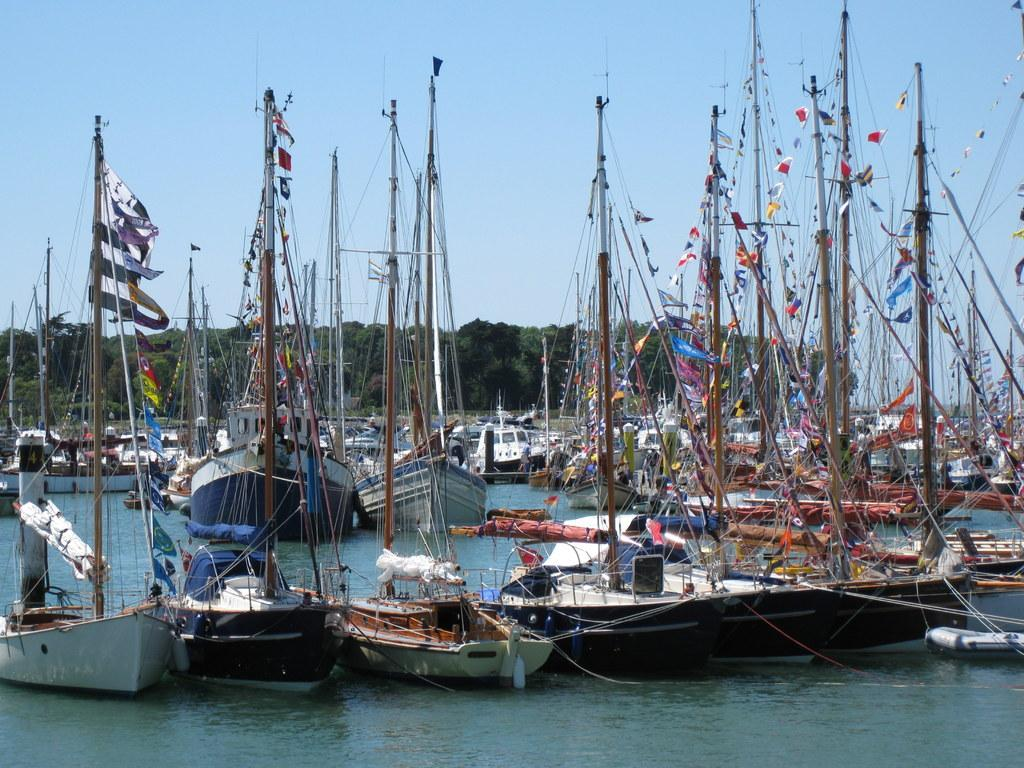What is in the water in the image? There are boats in the water in the image. What can be seen in the background of the image? There are trees and the sky visible in the background of the image. What type of linen is being used to create the magic in the image? There is no linen or magic present in the image; it features boats in the water and trees and the sky in the background. 